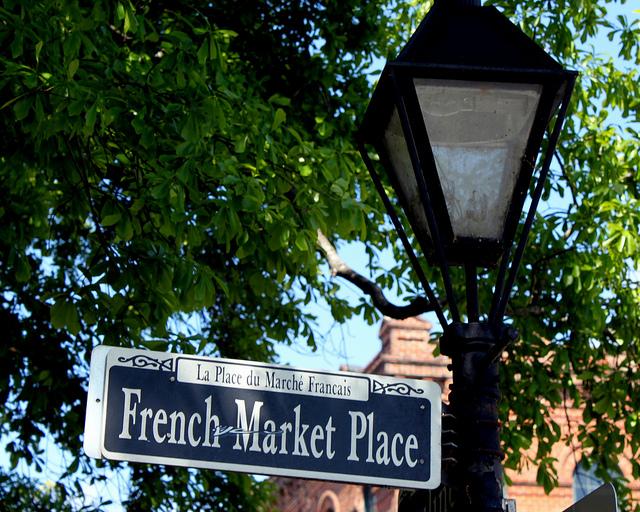What color is the streetlamp?
Short answer required. Black. What are the two languages on the nameplate?
Be succinct. French and english. What is the English phrase on the sign?
Give a very brief answer. French market place. 